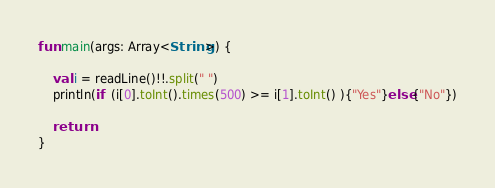Convert code to text. <code><loc_0><loc_0><loc_500><loc_500><_Kotlin_>fun main(args: Array<String>) {

    val i = readLine()!!.split(" ")
    println(if  (i[0].toInt().times(500) >= i[1].toInt() ){"Yes"}else{"No"})

    return
}</code> 